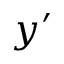<formula> <loc_0><loc_0><loc_500><loc_500>y ^ { \prime }</formula> 